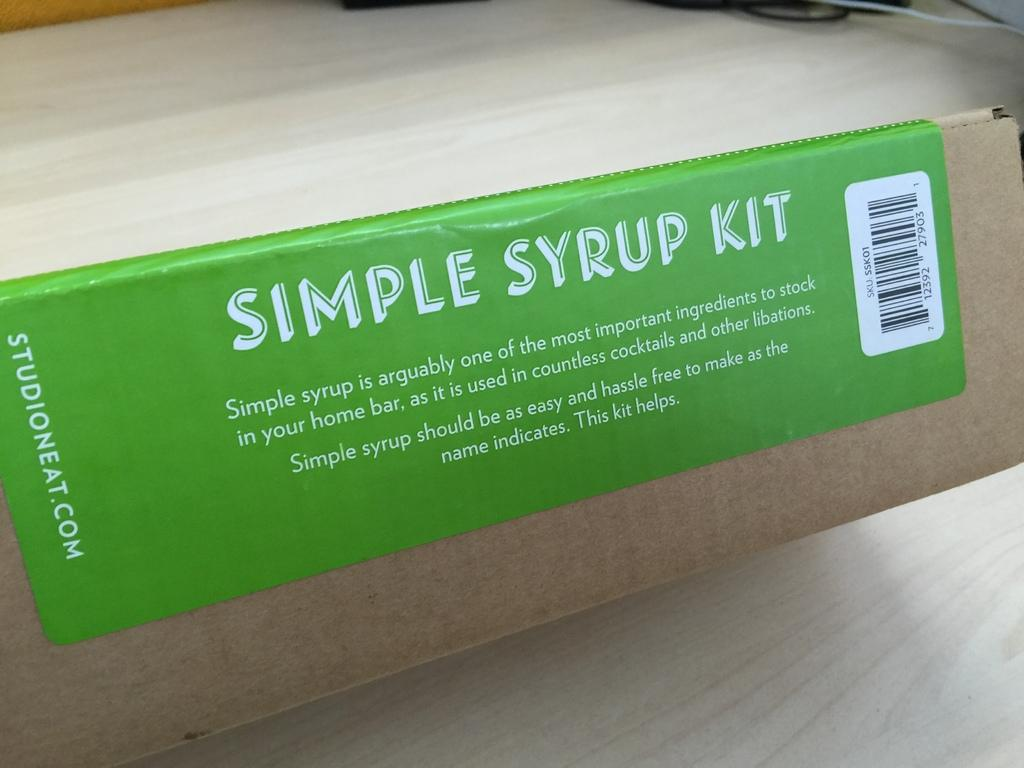Provide a one-sentence caption for the provided image. A green label reads"Simple Syrup Kit" in white letters. 